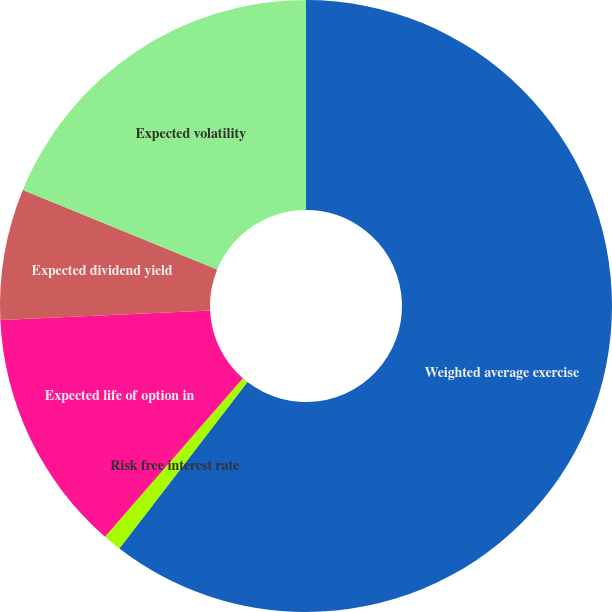Convert chart. <chart><loc_0><loc_0><loc_500><loc_500><pie_chart><fcel>Weighted average exercise<fcel>Risk free interest rate<fcel>Expected life of option in<fcel>Expected dividend yield<fcel>Expected volatility<nl><fcel>60.44%<fcel>0.97%<fcel>12.86%<fcel>6.92%<fcel>18.81%<nl></chart> 